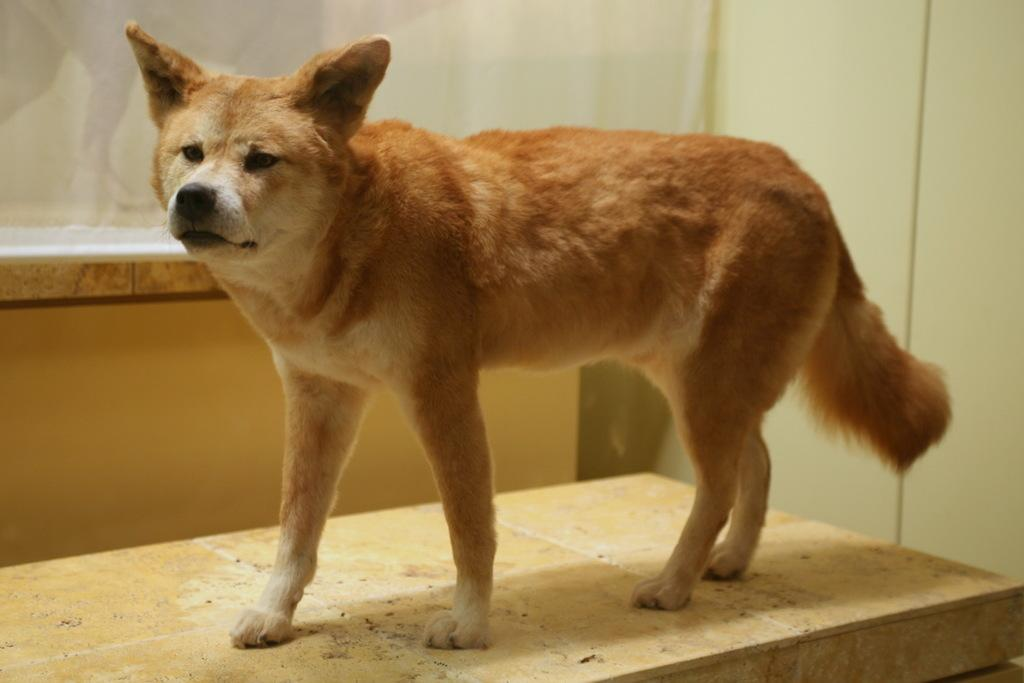What animal is standing in the image? There is a dog standing in the image. What can be seen in the background of the image? There is a glass door in the background of the image. What is on the right side of the image? There is a wall on the right side of the image. What type of pain is the dog experiencing in the image? There is no indication in the image that the dog is experiencing any pain. 